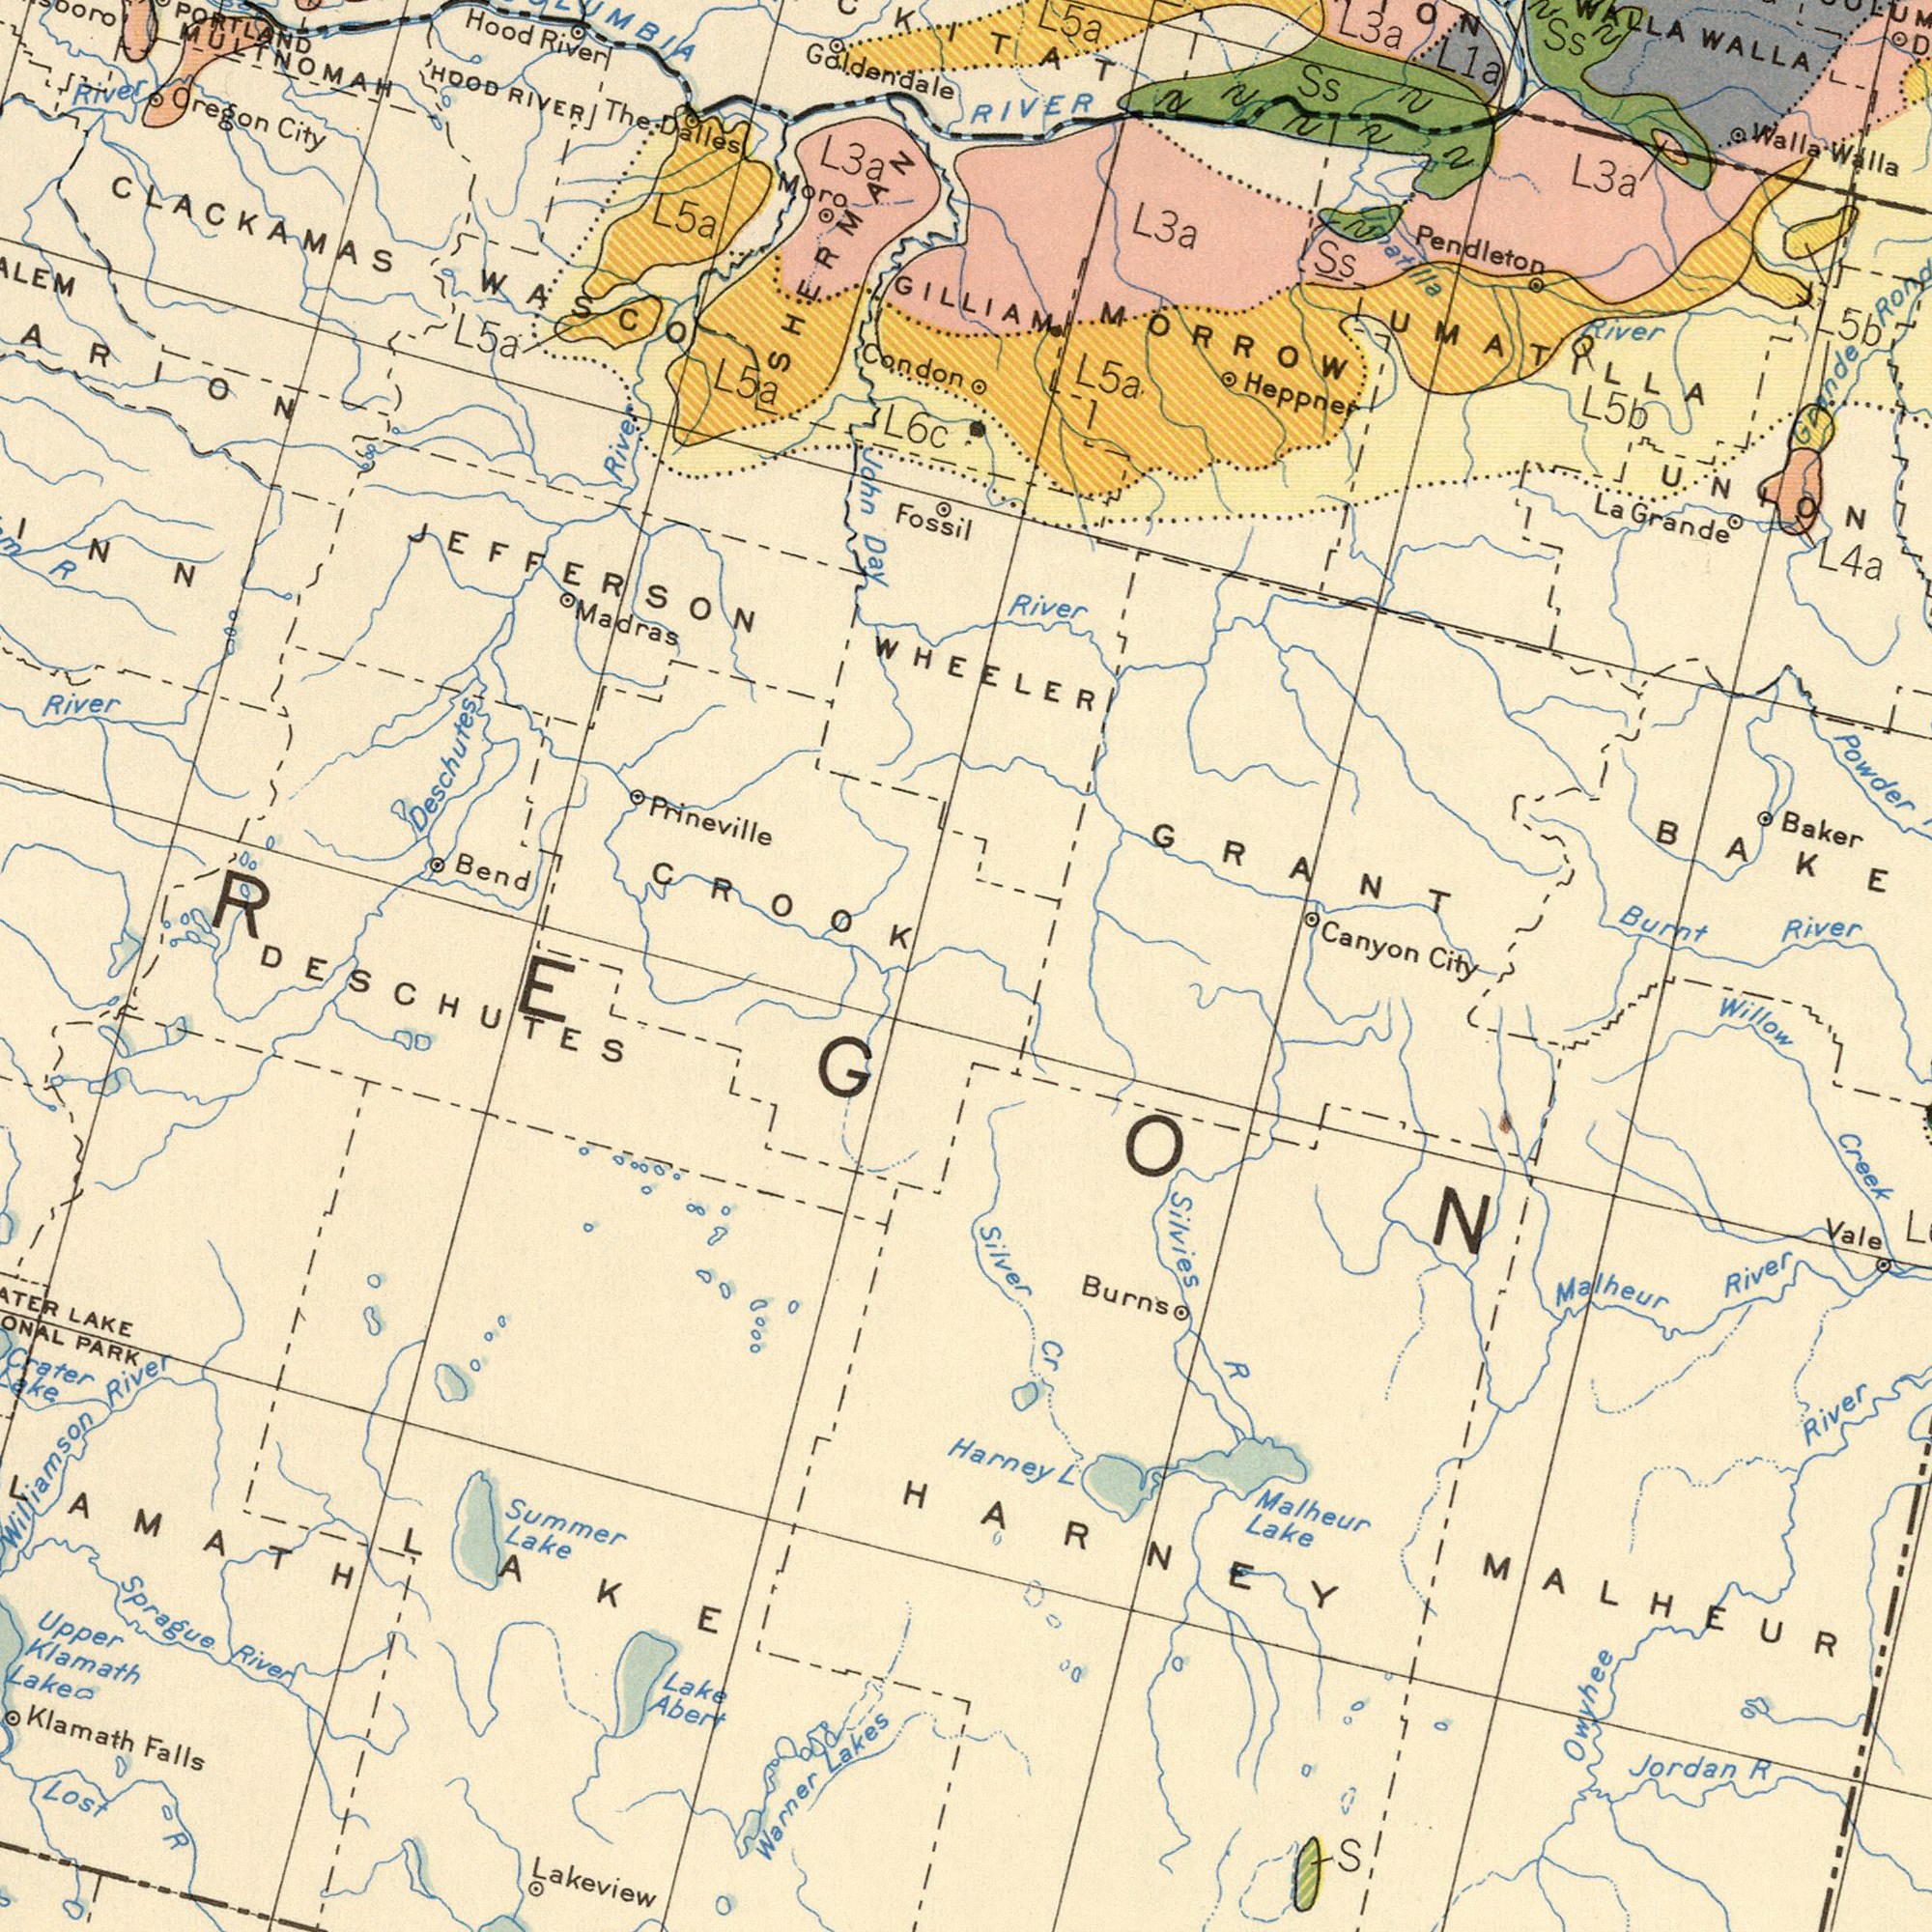What text appears in the bottom-left area of the image? Lakeview Sprague Summer Klamath LAKE Upper Lost PARK Klamath Lake Warner River Falls Lake Abert Crater Lakes R Lake River Williamson ###REGON DESCHUTES LAKE What text is visible in the upper-right corner? GILLIAM Powder Pendleton MORROW GRANT Canyon River Heppner Burnt Grande L1a RIVER WALLA Grande River L3a La UMATILAA L3a Ss Walla L5a L5b L5b Ss Walla Matilla River Baker Ss UNION L4a WHEELER What text can you see in the top-left section? Galdendale River Prineville Condon John Deschutes City Madras Bend MULTNOMAH River L5a CLACKAMAS L6c RIVER Hood River Moro CROOK HOOD The L5a Day Dalles River WASCO JEFFERSON L3a PORTLAND Oregon SHERRMAN L5a R Fossil What text is shown in the bottom-right quadrant? Silvies Malheur Willow Burns Lake River River Owyhee R Jordan Harney Vale R Creek Silver Malheur MALHEUR Cr S L City HARNEY 